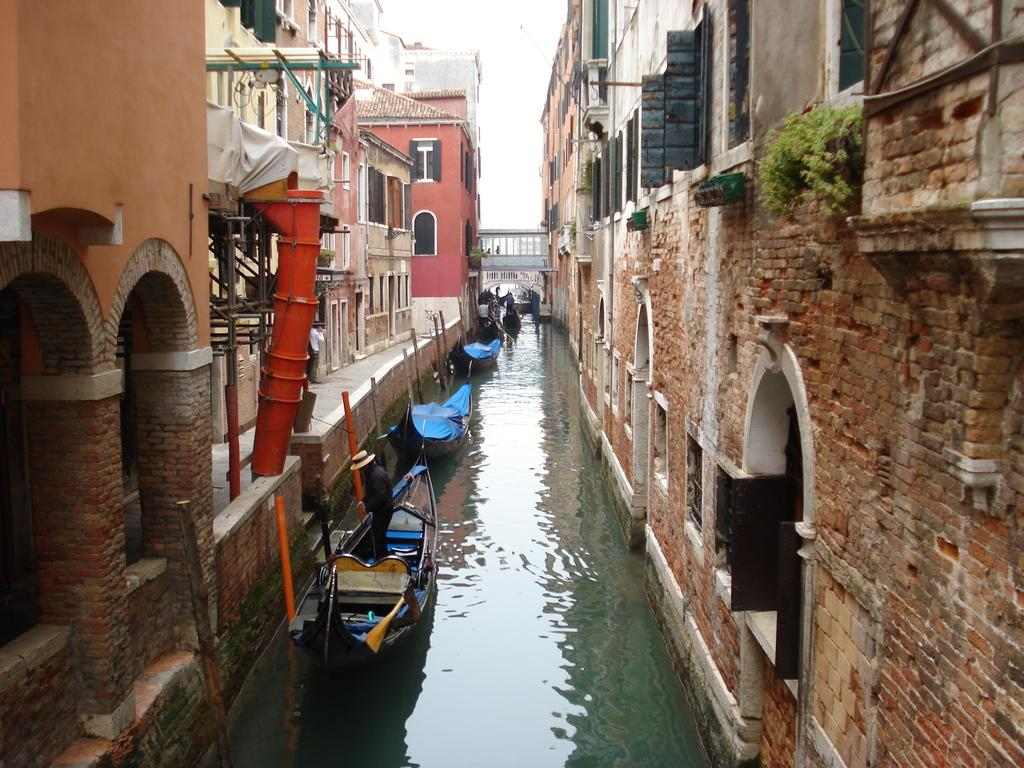What is on the water in the image? There are boats on the water in the image. What can be seen on both sides of the water? There are buildings on both sides of the water. What is visible in the background of the image? There is a bridge and the sky visible in the background of the image. What type of process is being carried out by the boats in the image? There is no indication of a process being carried out by the boats in the image; they are simply on the water. What is the weather like in the image? The provided facts do not mention the weather, so we cannot determine the weather from the image. 